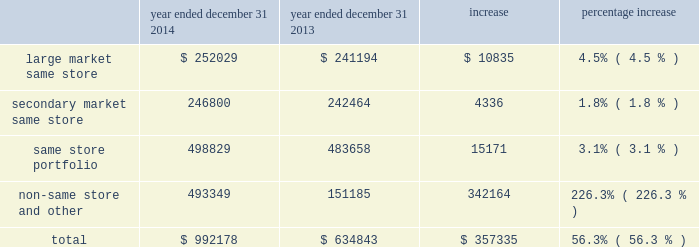Dispositions of depreciable real estate assets excluded from discontinued operations we recorded a gain on sale of depreciable assets excluded from discontinued operations of $ 190.0 million for the year ended december 31 , 2015 , an increase of approximately $ 147.3 million from the $ 42.6 million gain on sale of depreciable assets recorded for the year ended december 31 , 2014 .
The increase was primarily the result of increased disposition activity .
Dispositions increased from eight multifamily properties for the year ended december 31 , 2014 , to 21 multifamily properties for the year ended december 31 , 2015 .
Gain from real estate joint ventures we recorded a gain from real estate joint ventures of $ 6.0 million during the year ended december 31 , 2014 as opposed to no material gain or loss being recorded during the year ended december 31 , 2015 .
The decrease was primarily a result of recording a $ 3.4 million gain for the disposition of ansley village by mid-america multifamily fund ii , or fund ii , as well as a $ 2.8 million gain for the promote fee received from our fund ii partner during 2014 .
The promote fee was received as a result of maa achieving certain performance metrics in its management of the fund ii properties over the life of the joint venture .
There were no such gains recorded during the year ended december 31 , 2015 .
Discontinued operations we recorded a gain on sale of discontinued operations of $ 5.4 million for the year ended december 31 , 2014 .
We did not record a gain or loss on sale of discontinued operations during the year ended december 31 , 2015 , due to the adoption of asu 2014-08 , reporting discontinued operations and disclosures of disposals of components of an entity , which resulted in dispositions being included in the gain on sale of depreciable real estate assets excluded from discontinued operations and is discussed further below .
Net income attributable to noncontrolling interests net income attributable to noncontrolling interests for the year ended december 31 , 2015 was approximately $ 18.5 million , an increase of $ 10.2 million from the year ended december 31 , 2014 .
This increase is consistent with the increase to overall net income and is primarily a result of the items discussed above .
Net income attributable to maa primarily as a result of the items discussed above , net income attributable to maa increased by approximately $ 184.3 million in the year ended december 31 , 2015 from the year ended december 31 , 2014 .
Comparison of the year ended december 31 , 2014 to the year ended december 31 , 2013 the comparison of the year ended december 31 , 2014 to the year ended december 31 , 2013 shows the segment break down based on the 2014 same store portfolios .
A comparison using the 2015 same store portfolio would not be comparative due to the nature of the classifications as a result of the merger .
Property revenues the table shows our property revenues by segment for the years ended december 31 , 2014 and december 31 , 2013 ( dollars in thousands ) : year ended december 31 , 2014 year ended december 31 , 2013 increase percentage increase .
Job title mid-america apartment 10-k revision 1 serial <12345678> date sunday , march 20 , 2016 job number 304352-1 type page no .
51 operator abigaels .
What was the ratio of the property revenues for the large market same store to the secondary market same store in 2014? 
Rationale: the ratio of the property revenues for the large market same store to the secondary market same store in 2014 was 1.02 to 1
Computations: (252029 / 246800)
Answer: 1.02119. 